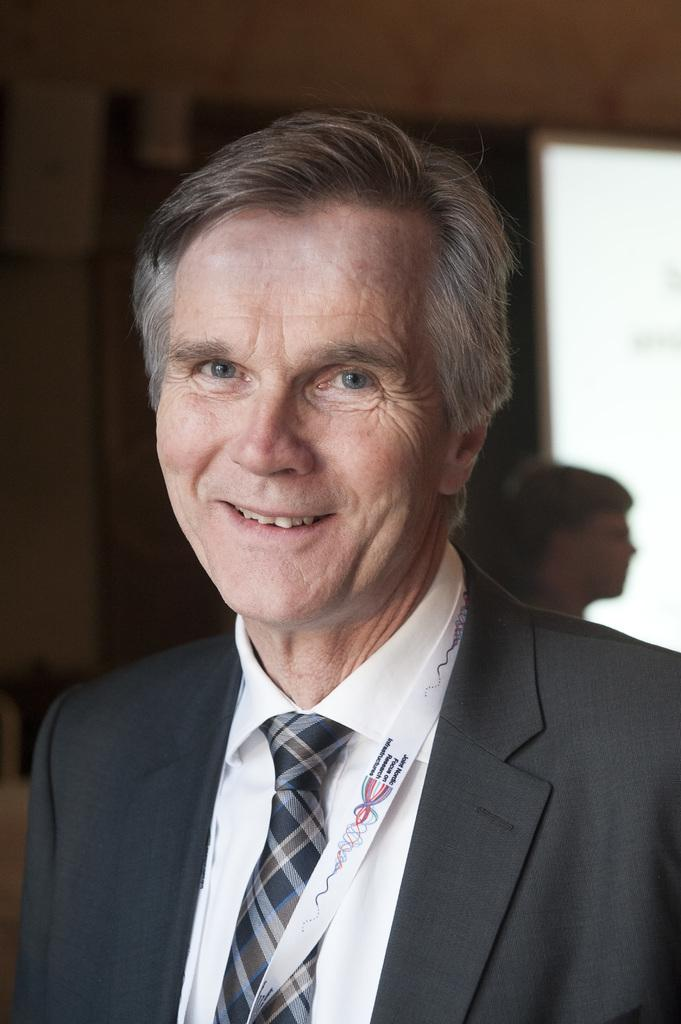Who is present in the image? There is a man in the image. What is the man doing in the image? The man is smiling in the image. What can be seen in the background of the image? There is a wall in the background of the image. Are there any other people visible in the image? Yes, there is a person visible in the background of the image. What type of toys can be seen on the man's trousers in the image? There are no toys visible on the man's trousers in the image. What time of day is it in the image? The provided facts do not give any information about the time of day in the image. 